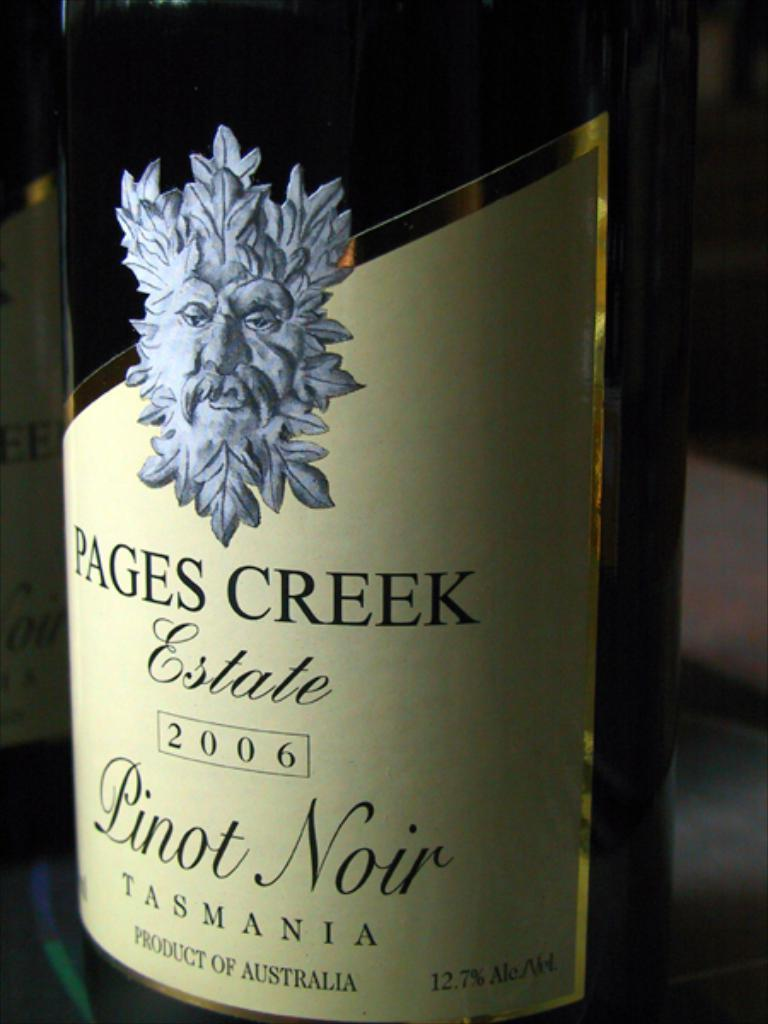What is the main object in the image? There is a wine bottle in the image. Where is the wine bottle located? The wine bottle is placed on a table. How many rabbits are playing with the grape in the image? There are no rabbits or grapes present in the image; it only features a wine bottle placed on a table. 